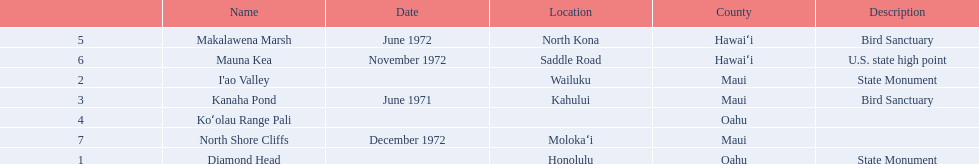What are the natural landmarks in hawaii(national)? Diamond Head, I'ao Valley, Kanaha Pond, Koʻolau Range Pali, Makalawena Marsh, Mauna Kea, North Shore Cliffs. Of these which is described as a u.s state high point? Mauna Kea. 